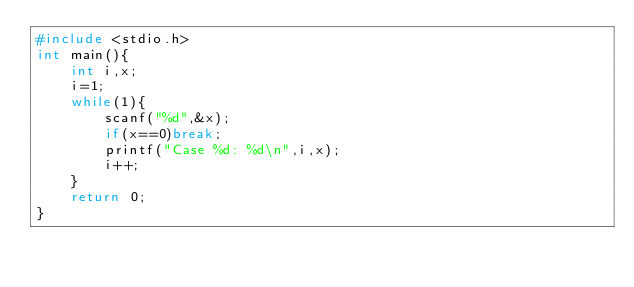<code> <loc_0><loc_0><loc_500><loc_500><_C_>#include <stdio.h>
int main(){
    int i,x;
    i=1;
    while(1){
        scanf("%d",&x);
        if(x==0)break;
        printf("Case %d: %d\n",i,x);
        i++;
    }
    return 0;
}</code> 